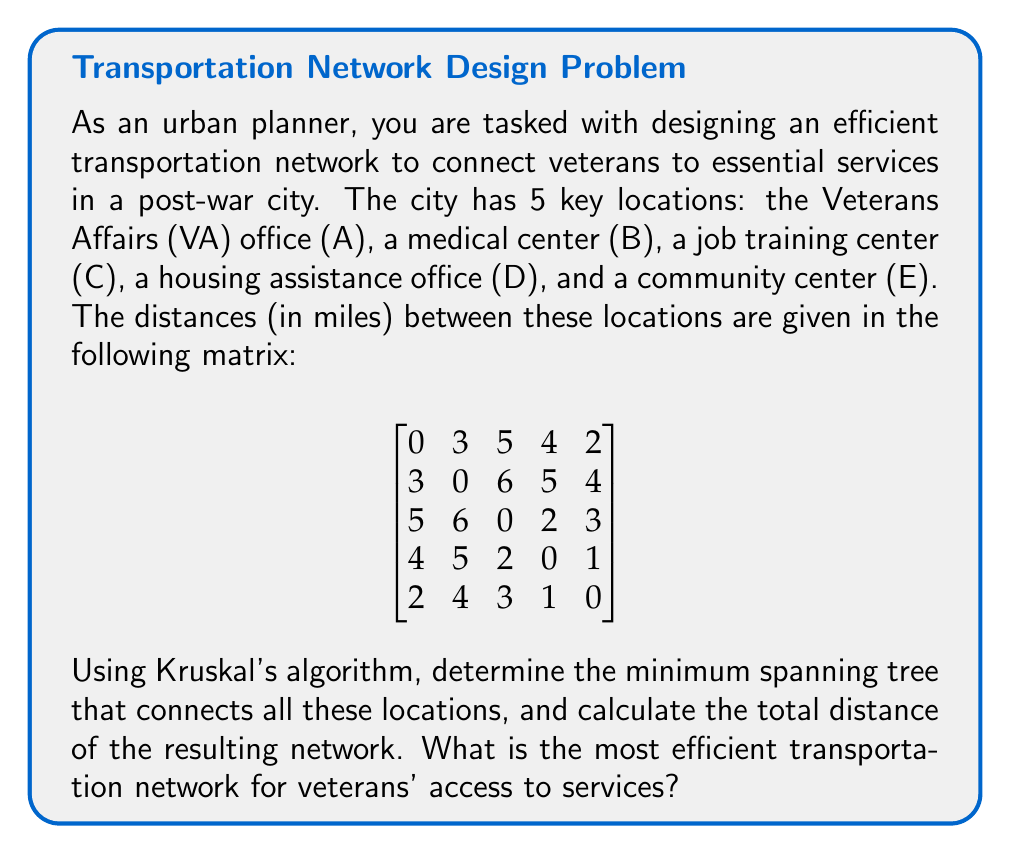Provide a solution to this math problem. To solve this problem, we'll use Kruskal's algorithm to find the minimum spanning tree (MST) of the given graph. This will provide the most efficient transportation network connecting all the key locations for veterans' services.

Step 1: Sort all edges in ascending order of weight (distance).
1. D-E: 1 mile
2. A-E: 2 miles
3. C-D: 2 miles
4. A-B: 3 miles
5. C-E: 3 miles
6. A-D: 4 miles
7. B-E: 4 miles
8. A-C: 5 miles
9. B-D: 5 miles
10. B-C: 6 miles

Step 2: Apply Kruskal's algorithm:
1. Add D-E (1 mile)
2. Add A-E (2 miles)
3. Add C-D (2 miles)
4. Add A-B (3 miles)

At this point, all vertices are connected, and we have a minimum spanning tree.

The resulting MST can be visualized as follows:

[asy]
unitsize(30);
pair A = (0,2), B = (2,2), C = (2,0), D = (1,0), E = (0,1);
draw(A--E--D--C, blue+1);
draw(A--B, blue+1);
dot("A", A, N);
dot("B", B, N);
dot("C", C, S);
dot("D", D, S);
dot("E", E, W);
label("2", (A+E)/2, NW);
label("3", (A+B)/2, N);
label("1", (D+E)/2, W);
label("2", (C+D)/2, S);
[/asy]

Step 3: Calculate the total distance of the MST:
Total distance = DE + AE + CD + AB
                = 1 + 2 + 2 + 3
                = 8 miles

Therefore, the most efficient transportation network for veterans' access to services has a total distance of 8 miles and connects the locations as shown in the diagram above.
Answer: The most efficient transportation network for veterans' access to services is a minimum spanning tree with a total distance of 8 miles, connecting the locations in the following order: D-E, A-E, C-D, and A-B. 